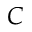Convert formula to latex. <formula><loc_0><loc_0><loc_500><loc_500>C</formula> 